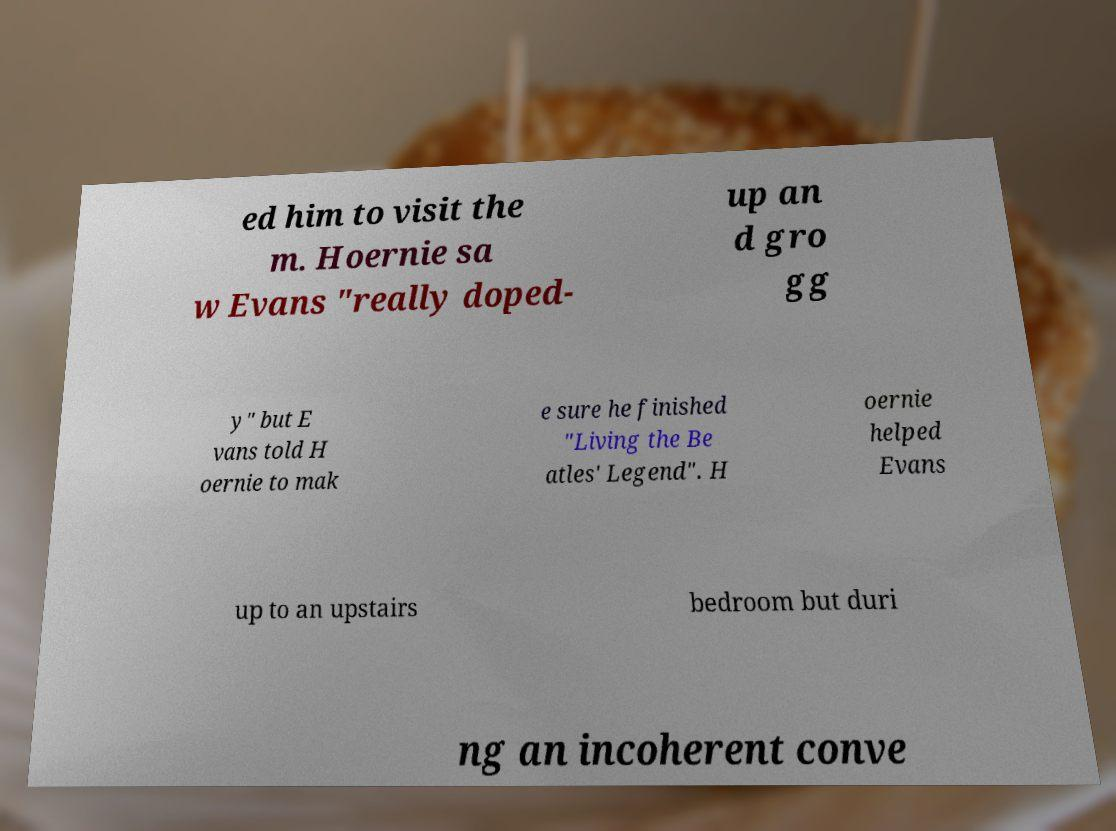For documentation purposes, I need the text within this image transcribed. Could you provide that? ed him to visit the m. Hoernie sa w Evans "really doped- up an d gro gg y" but E vans told H oernie to mak e sure he finished "Living the Be atles' Legend". H oernie helped Evans up to an upstairs bedroom but duri ng an incoherent conve 